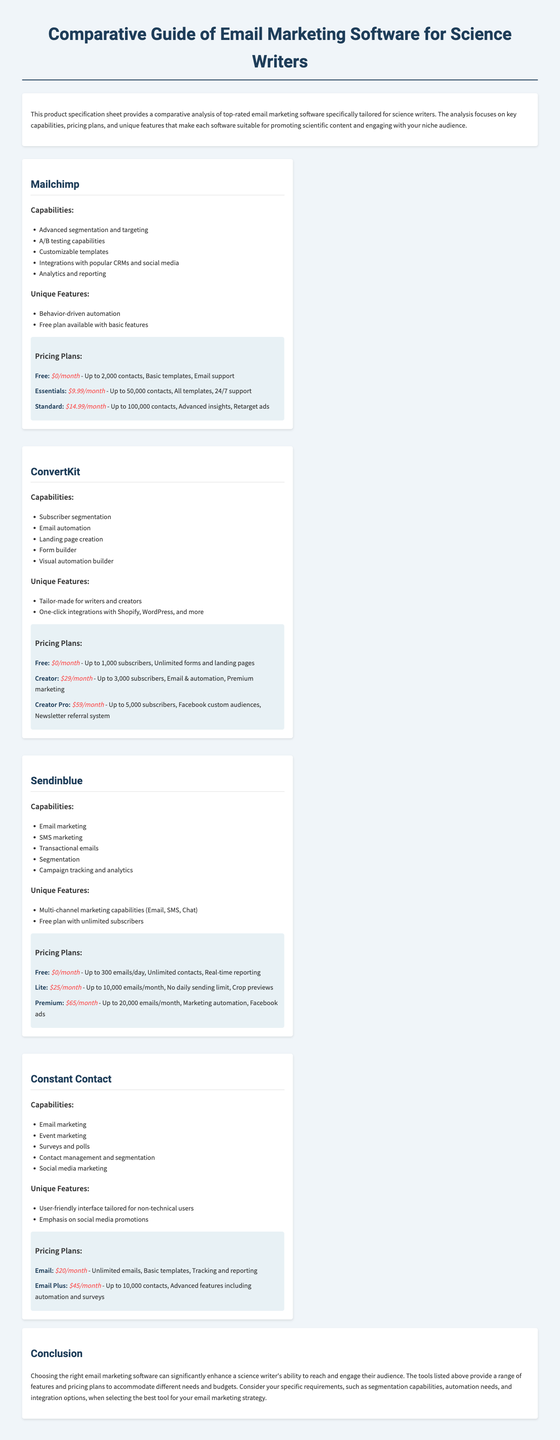What is the first software listed? The first software mentioned in the document is Mailchimp, which is listed as the top-rated email marketing software for science writers.
Answer: Mailchimp How much does the ConvertKit Creator Pro plan cost? The document specifies that the ConvertKit Creator Pro plan costs 59 dollars per month.
Answer: $59/month What unique feature does Sendinblue provide? Sendinblue offers multi-channel marketing capabilities, such as Email, SMS, and Chat, which distinguish it from the other software options listed.
Answer: Multi-channel marketing capabilities (Email, SMS, Chat) How many contacts can the free plan of Mailchimp accommodate? The free plan of Mailchimp allows for up to 2,000 contacts, which is specified under the pricing plans section.
Answer: 2,000 contacts What is included in Constant Contact's Email Plus plan? The Email Plus plan of Constant Contact includes advanced features such as automation and surveys, in addition to the 10,000 contact limit.
Answer: Advanced features including automation and surveys What software is primarily designed for writers and creators? ConvertKit is mentioned as being tailor-made specifically for writers and creators in the document.
Answer: ConvertKit How many emails can you send with the free plan of Sendinblue? According to the document, the free plan of Sendinblue permits sending up to 300 emails per day.
Answer: 300 emails/day What is the price of Mailchimp's Essentials plan? The document specifies that the Essentials plan of Mailchimp costs 9.99 dollars per month.
Answer: $9.99/month What capability is listed for Constant Contact? The capabilities of Constant Contact include email marketing, event marketing, and surveys and polls, among others specified.
Answer: Email marketing 